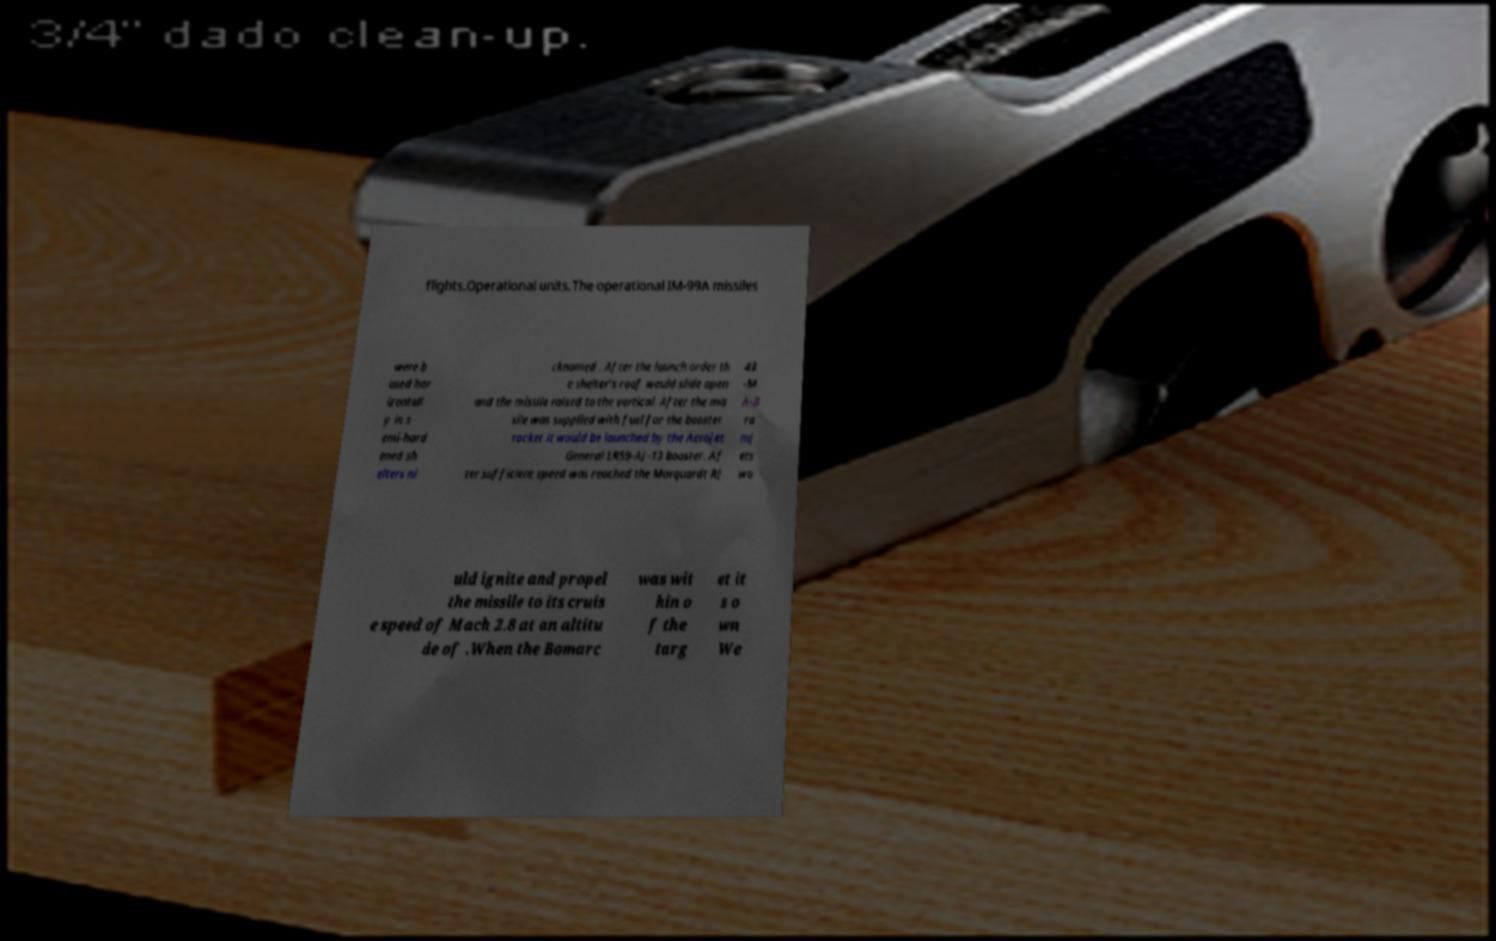Could you assist in decoding the text presented in this image and type it out clearly? flights.Operational units.The operational IM-99A missiles were b ased hor izontall y in s emi-hard ened sh elters ni cknamed . After the launch order th e shelter's roof would slide open and the missile raised to the vertical. After the mis sile was supplied with fuel for the booster rocket it would be launched by the Aerojet General LR59-AJ-13 booster. Af ter sufficient speed was reached the Marquardt RJ 43 -M A-3 ra mj ets wo uld ignite and propel the missile to its cruis e speed of Mach 2.8 at an altitu de of .When the Bomarc was wit hin o f the targ et it s o wn We 